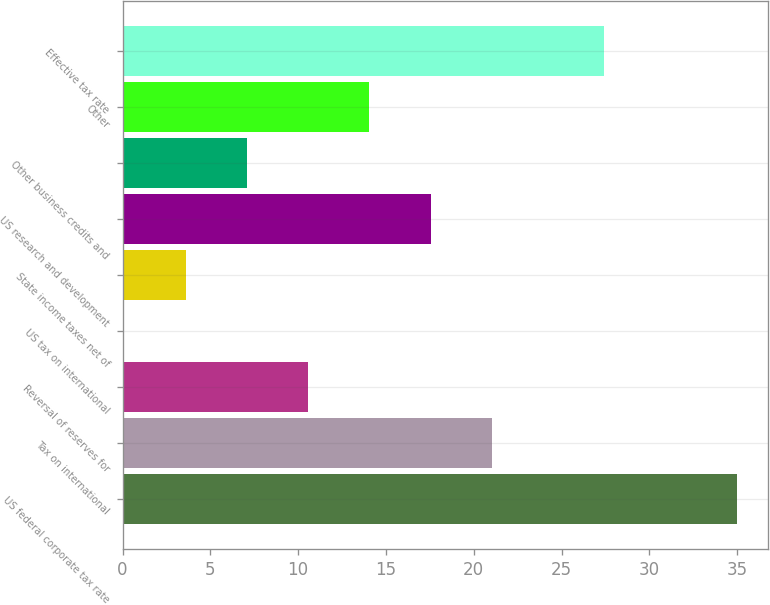Convert chart. <chart><loc_0><loc_0><loc_500><loc_500><bar_chart><fcel>US federal corporate tax rate<fcel>Tax on international<fcel>Reversal of reserves for<fcel>US tax on international<fcel>State income taxes net of<fcel>US research and development<fcel>Other business credits and<fcel>Other<fcel>Effective tax rate<nl><fcel>35<fcel>21.04<fcel>10.57<fcel>0.1<fcel>3.59<fcel>17.55<fcel>7.08<fcel>14.06<fcel>27.4<nl></chart> 